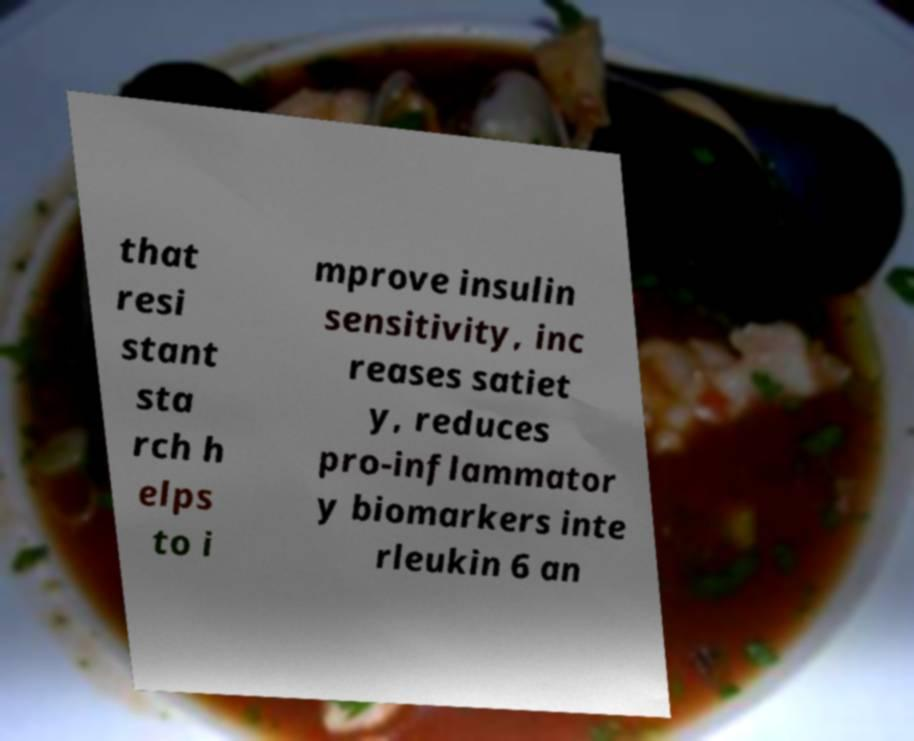There's text embedded in this image that I need extracted. Can you transcribe it verbatim? that resi stant sta rch h elps to i mprove insulin sensitivity, inc reases satiet y, reduces pro-inflammator y biomarkers inte rleukin 6 an 